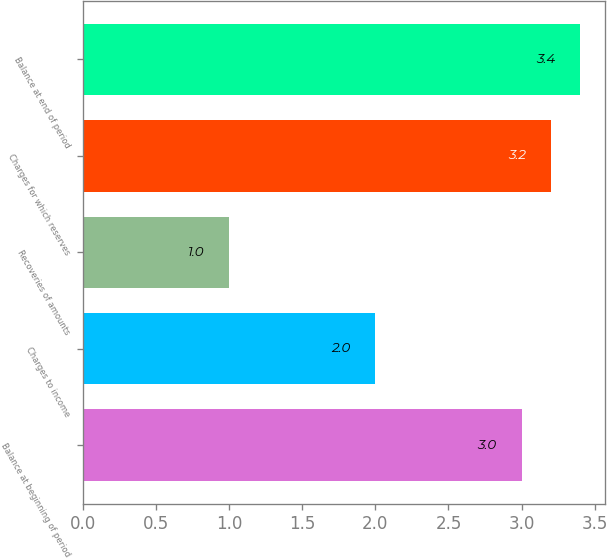Convert chart. <chart><loc_0><loc_0><loc_500><loc_500><bar_chart><fcel>Balance at beginning of period<fcel>Charges to income<fcel>Recoveries of amounts<fcel>Charges for which reserves<fcel>Balance at end of period<nl><fcel>3<fcel>2<fcel>1<fcel>3.2<fcel>3.4<nl></chart> 